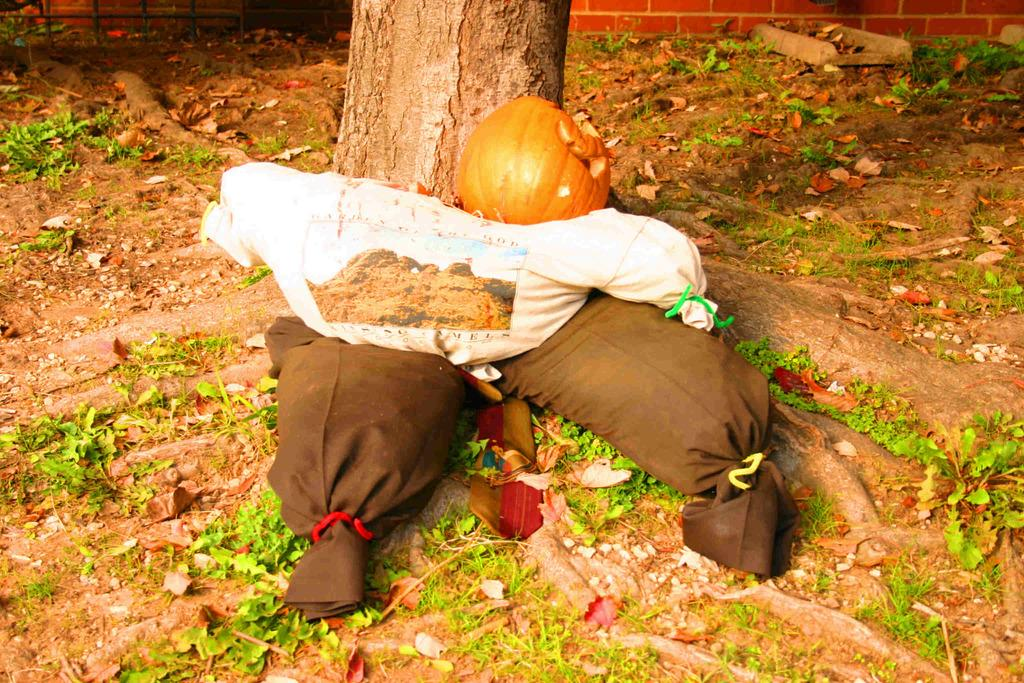What items can be seen in the image related to clothing? There are clothes in the image. What seasonal item is present in the image? There is a pumpkin in the image. What type of ground surface is visible in the image? There is grass on the ground in the image. What can be seen in the distance in the image? There is a tree and a wall in the background of the image, as well as rods. How many babies are crawling on the grass in the image? There are no babies present in the image; it features clothes, a pumpkin, grass, and various background elements. What type of field is visible in the image? There is no field visible in the image; it features a tree, a wall, and rods in the background. 